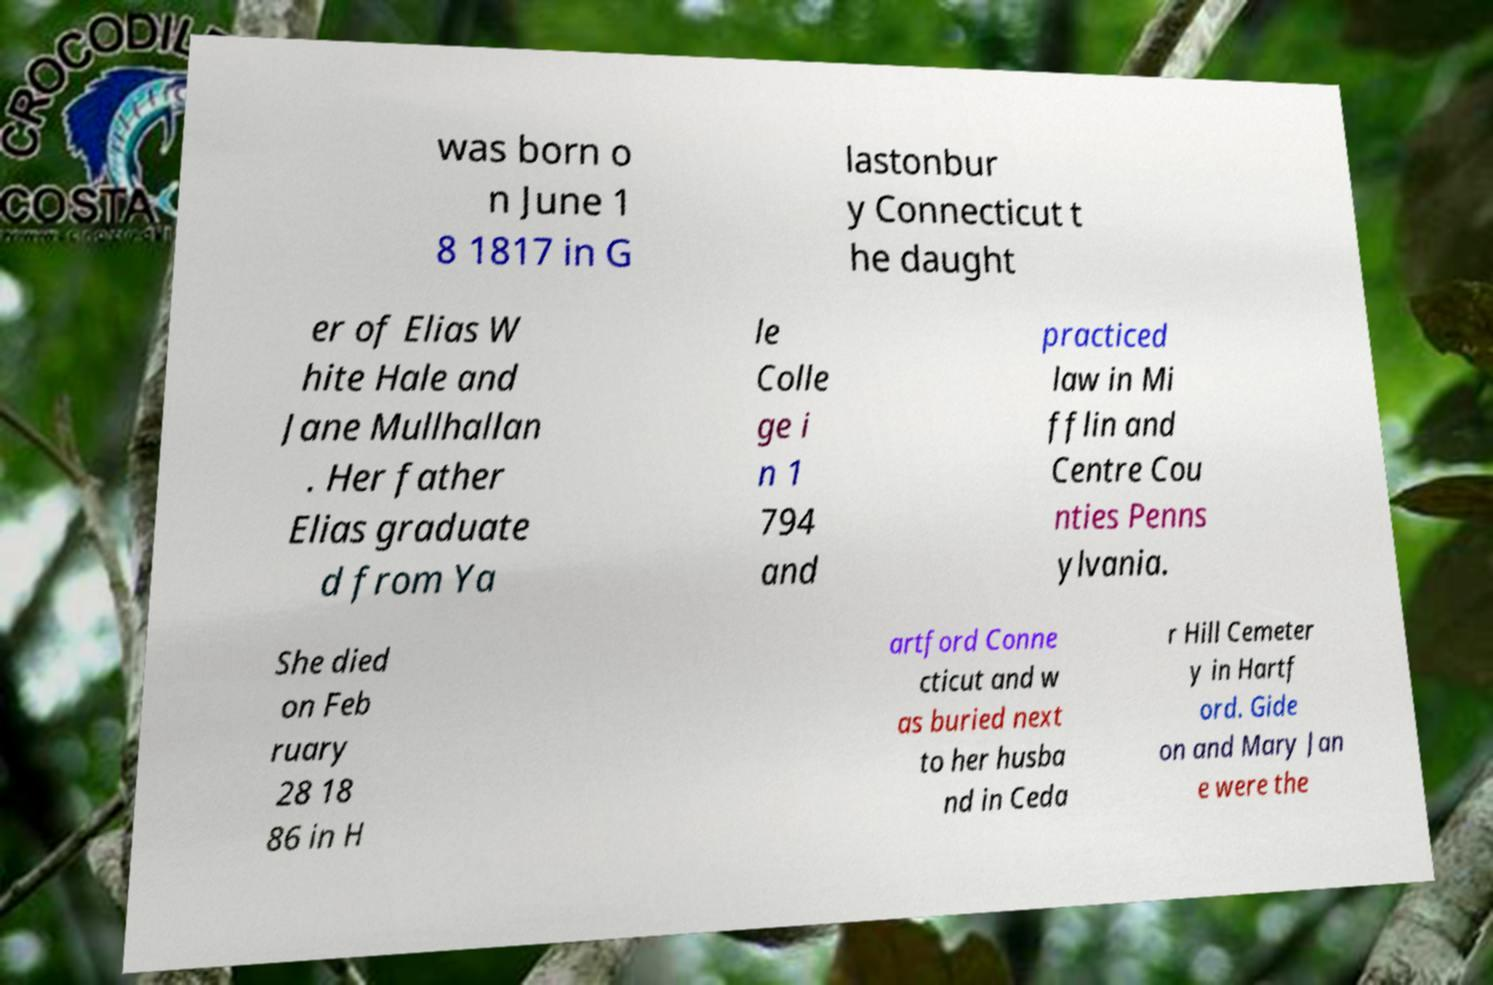Can you accurately transcribe the text from the provided image for me? was born o n June 1 8 1817 in G lastonbur y Connecticut t he daught er of Elias W hite Hale and Jane Mullhallan . Her father Elias graduate d from Ya le Colle ge i n 1 794 and practiced law in Mi fflin and Centre Cou nties Penns ylvania. She died on Feb ruary 28 18 86 in H artford Conne cticut and w as buried next to her husba nd in Ceda r Hill Cemeter y in Hartf ord. Gide on and Mary Jan e were the 